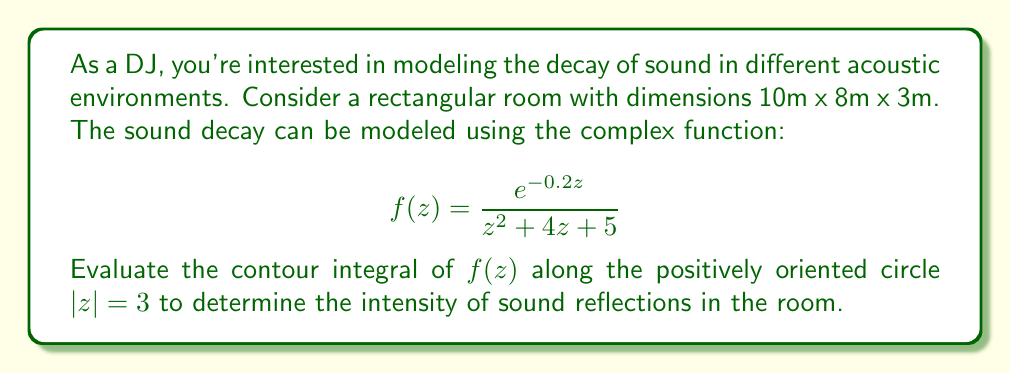Can you solve this math problem? To solve this problem, we'll use the Residue Theorem. The steps are as follows:

1) First, we need to find the poles of the function inside the contour $|z| = 3$. The denominator of $f(z)$ is $z^2 + 4z + 5 = (z+2)^2 + 1$, which has roots at $z = -2 \pm i$.

2) Both of these poles lie inside the contour $|z| = 3$, as $|-2+i| = |-2-i| = \sqrt{5} < 3$.

3) Now, we calculate the residues at these poles:

   For $z_1 = -2 + i$:
   $$\text{Res}(f, z_1) = \lim_{z \to -2+i} (z-(-2+i))f(z) = \frac{e^{-0.2(-2+i)}}{2i} = \frac{e^{0.4-0.2i}}{2i}$$

   For $z_2 = -2 - i$:
   $$\text{Res}(f, z_2) = \lim_{z \to -2-i} (z-(-2-i))f(z) = \frac{e^{-0.2(-2-i)}}{-2i} = -\frac{e^{0.4+0.2i}}{2i}$$

4) By the Residue Theorem:
   $$\oint_{|z|=3} f(z) dz = 2\pi i (\text{Res}(f, z_1) + \text{Res}(f, z_2))$$

5) Substituting the residues:
   $$\oint_{|z|=3} f(z) dz = 2\pi i (\frac{e^{0.4-0.2i}}{2i} - \frac{e^{0.4+0.2i}}{2i})$$

6) Simplifying:
   $$\oint_{|z|=3} f(z) dz = \pi (e^{0.4-0.2i} - e^{0.4+0.2i}) = -2\pi i e^{0.4} \sin(0.2)$$

This result represents the intensity of sound reflections in the room, where the real part corresponds to the magnitude and the imaginary part to the phase shift.
Answer: $$-2\pi i e^{0.4} \sin(0.2)$$ 